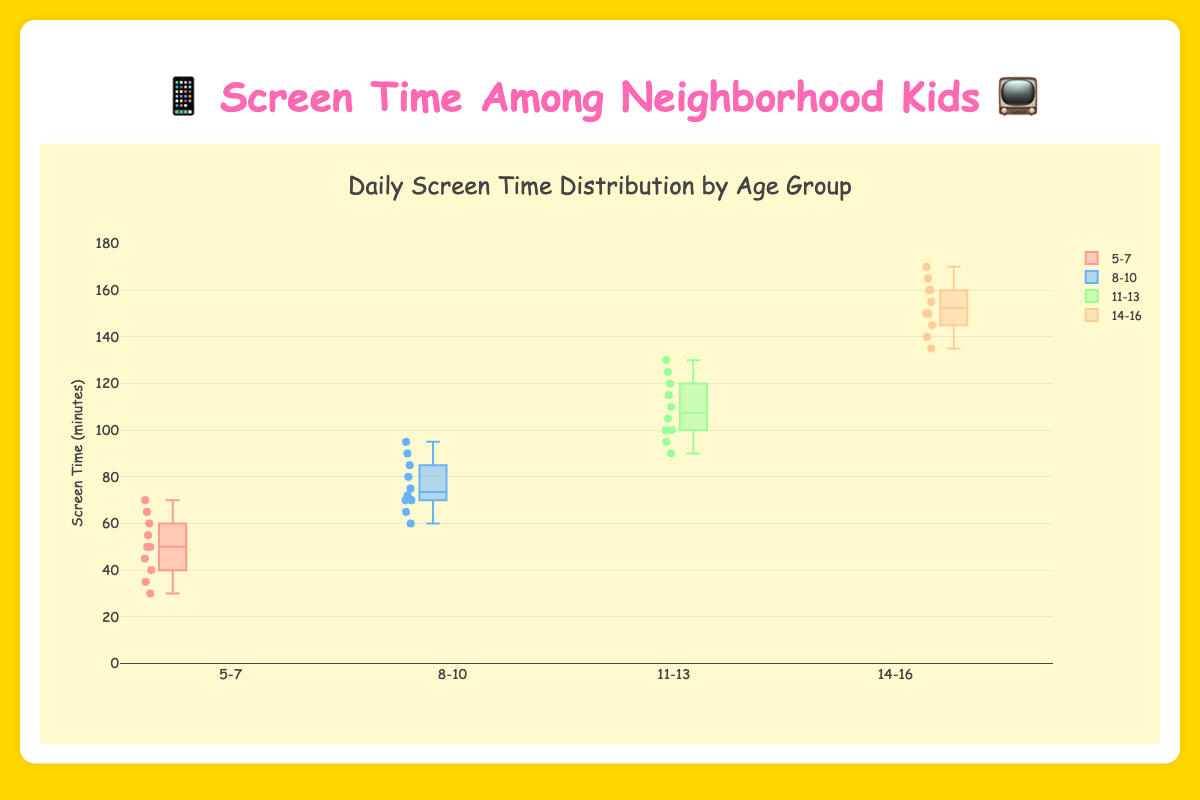What age group has the highest maximum screen time? The age group 14-16 has a maximum screen time of 170 minutes, which is the highest among all the age groups in the plot.
Answer: 14-16 Which age group has the lowest median screen time? The age group 5-7 has the lowest median screen time as it is the middle value of the box representing that group.
Answer: 5-7 What is the interquartile range (IQR) for the 8-10 age group? The interquartile range is the difference between the third quartile (Q3) and the first quartile (Q1). For the 8-10 age group, Q1 is around 70 and Q3 is around 85, so IQR = 85 - 70.
Answer: 15 How many age groups have a median screen time above 100 minutes? Both the 11-13 and 14-16 age groups have a median screen time above 100 minutes.
Answer: 2 Do all age groups have outliers? Not all age groups have outliers. The 8-10 age group does not show any outliers, while the others do.
Answer: No Which age group shows the most variability in screen time? The age group 14-16 has the widest range and interquartile range, indicating the most variability in screen time.
Answer: 14-16 What is the range of screen time for the 5-7 age group? The range is calculated by subtracting the minimum value from the maximum value. For the 5-7 age group, the range is 70 - 30.
Answer: 40 Between the 8-10 and 11-13 age groups, which one has a higher median screen time? The 11-13 age group has a higher median screen time compared to the 8-10 age group.
Answer: 11-13 